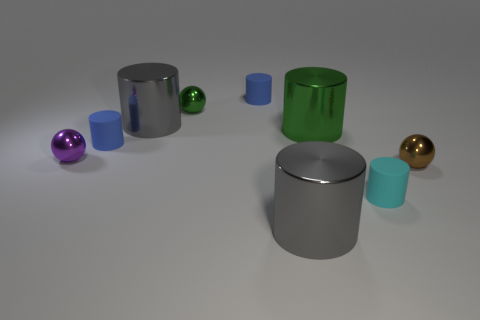Subtract all big green metallic cylinders. How many cylinders are left? 5 Add 1 cyan matte objects. How many objects exist? 10 Subtract all blue cylinders. How many cylinders are left? 4 Subtract all balls. How many objects are left? 6 Subtract all cyan cylinders. How many green spheres are left? 1 Add 7 big blue cylinders. How many big blue cylinders exist? 7 Subtract 1 cyan cylinders. How many objects are left? 8 Subtract 1 spheres. How many spheres are left? 2 Subtract all red cylinders. Subtract all blue spheres. How many cylinders are left? 6 Subtract all large cyan spheres. Subtract all small purple spheres. How many objects are left? 8 